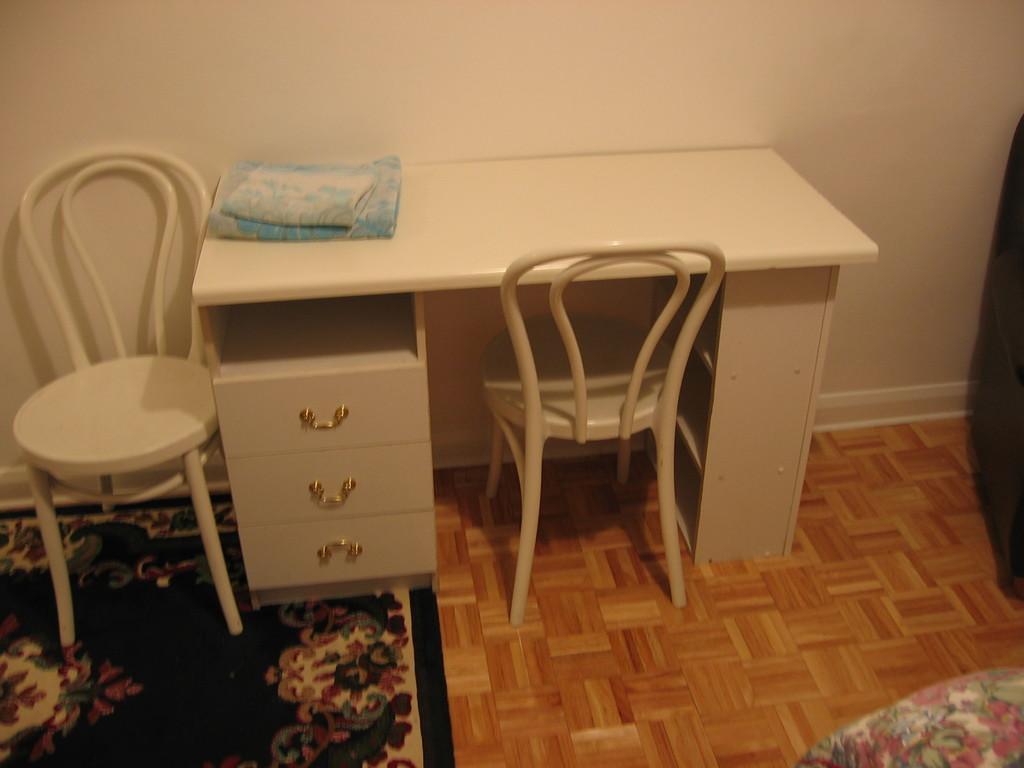In one or two sentences, can you explain what this image depicts? In this picture we can see inside view of the room. In the front there is a white table and chairs. In the front bottom side there is a blue carpet on the wooden flooring. Behind there is a white wall. 